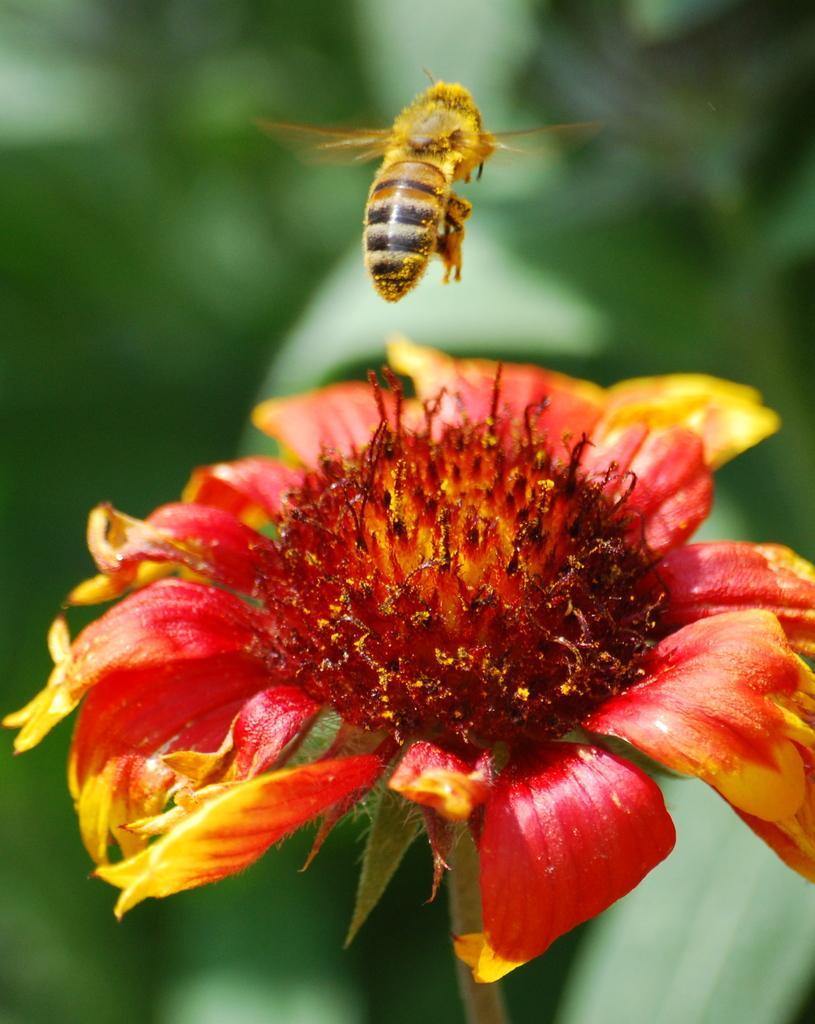Please provide a concise description of this image. In this image we can see a flower, honey bee, and the background is blurred. 